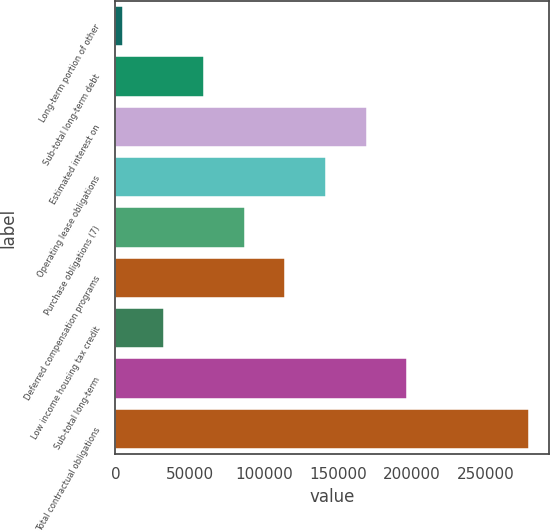Convert chart to OTSL. <chart><loc_0><loc_0><loc_500><loc_500><bar_chart><fcel>Long-term portion of other<fcel>Sub-total long-term debt<fcel>Estimated interest on<fcel>Operating lease obligations<fcel>Purchase obligations (7)<fcel>Deferred compensation programs<fcel>Low income housing tax credit<fcel>Sub-total long-term<fcel>Total contractual obligations<nl><fcel>5195<fcel>59921.6<fcel>169375<fcel>142012<fcel>87284.9<fcel>114648<fcel>32558.3<fcel>196738<fcel>278828<nl></chart> 